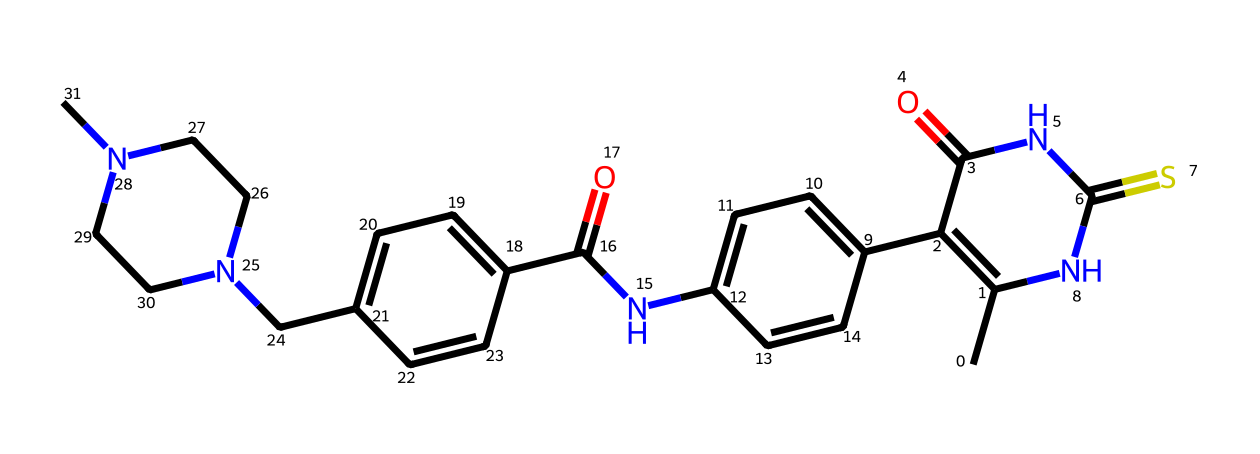What is the total number of nitrogen atoms in this chemical? Upon inspecting the SMILES representation, we can identify nitrogen (N) within the structure. By counting each occurrence of nitrogen symbols, we find there are four nitrogen atoms.
Answer: four How many rings does this compound contain? The chemical structure indicated in the SMILES shows multiple cyclic (ring) structures. By analyzing the connections in the SMILES, we see that there are three distinct rings present.
Answer: three What is the main functional group present in this molecule? The significant functional groups can be identified from the structure indicated in the SMILES. The presence of –C(=O)N– indicates that amide groups are present.
Answer: amide What is the total number of carbon atoms in this chemical? By reviewing the SMILES representation, we can count the number of carbon (C) symbols. Upon counting, it totals to 20 carbon atoms in the entire structure.
Answer: twenty Are there any stereocenters in the molecule? To determine the presence of stereocenters, we look for sp^3 hybridized carbon atoms that are connected to four different substituents. The SMILES structure shows no such carbons, indicating there are no stereocenters present.
Answer: no What type of chemical is this compound classified as? Analyzing the structure, particularly the presence of nitrogen and heterocyclic rings, this compound can be classified as a small-molecule epigenetic modifier, specifically a histone deacetylase inhibitor.
Answer: histone deacetylase inhibitor 